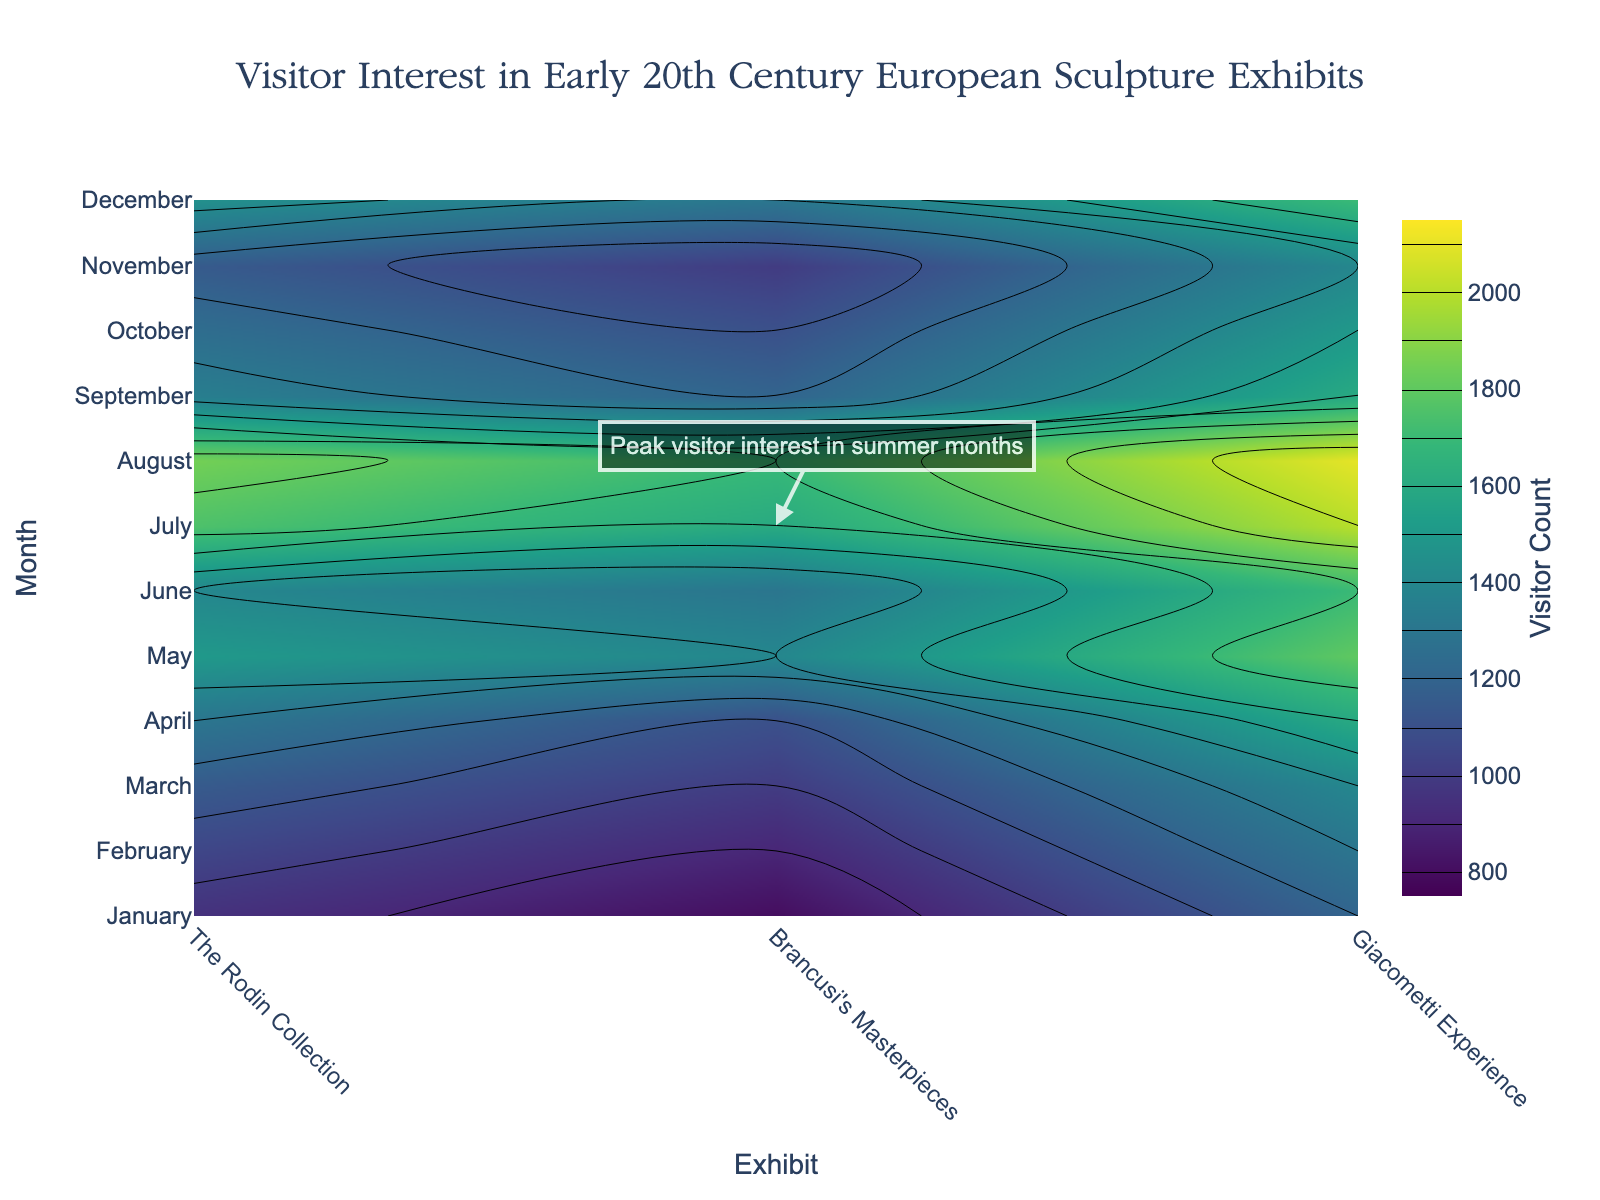What is the title of the figure? The title is prominently displayed at the top of the figure, stating the main focus of the plot.
Answer: Visitor Interest in Early 20th Century European Sculpture Exhibits Which month shows the highest visitor interest across all exhibits? Observe the contour peaks, which indicate the highest values. Notice that the highest visitor counts occur in August across all exhibits.
Answer: August What is the visitor count range represented by the contours? Reference the colorbar to identify the start and end values of the contours. The contours start at 800 and end at 2100, with increments of 100.
Answer: 800 to 2100 Are there any annotations in the figure? If so, what does it state? Look for any text outside of the axis labels and title, typically accompanied by an arrow. The annotation states "Peak visitor interest in summer months" and points to the higher values in summer.
Answer: Peak visitor interest in summer months Which exhibit had the highest visitor interest in the month of May? Trace May down the y-axis and identify the contour values for each exhibit. The Rodin Collection has values around 1800 in May, which is the highest among the exhibits.
Answer: The Rodin Collection Compare the visitor counts for each exhibit in January. Which exhibit had the lowest visitor count? Follow January on the y-axis and look at the contour lines for January's values. Compare The Rodin Collection (1200), Brancusi's Masterpieces (950), and Giacometti Experience (800). The Giacometti Experience has the lowest count.
Answer: Giacometti Experience What is the general trend of visitor interest from January to December for Brancusi's Masterpieces? Observe the contour lines for Brancusi's Masterpieces across the months. Visitor interest generally increases up to July and August and then decreases towards December.
Answer: Increasing up to August, then decreasing Estimate the average visitor count for The Rodin Collection during the summer months (June, July, August). Identify the contour values for The Rodin Collection in June (1700), July (2000), and August (2100). Calculate the average: (1700 + 2000 + 2100) / 3 = 1933.33.
Answer: 1933.33 During which month is there a significant drop in visitor interest across all exhibits? Look for a noticeable drop in contour values between adjacent months for all exhibits. This drop occurs from August to September.
Answer: September 